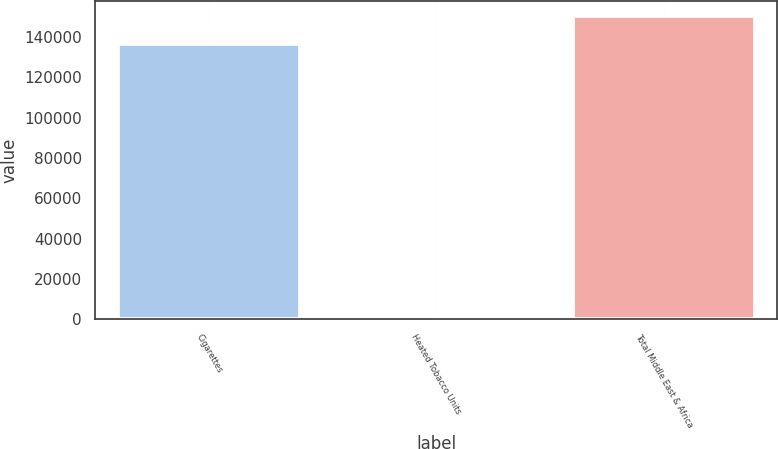Convert chart. <chart><loc_0><loc_0><loc_500><loc_500><bar_chart><fcel>Cigarettes<fcel>Heated Tobacco Units<fcel>Total Middle East & Africa<nl><fcel>136759<fcel>907<fcel>150435<nl></chart> 